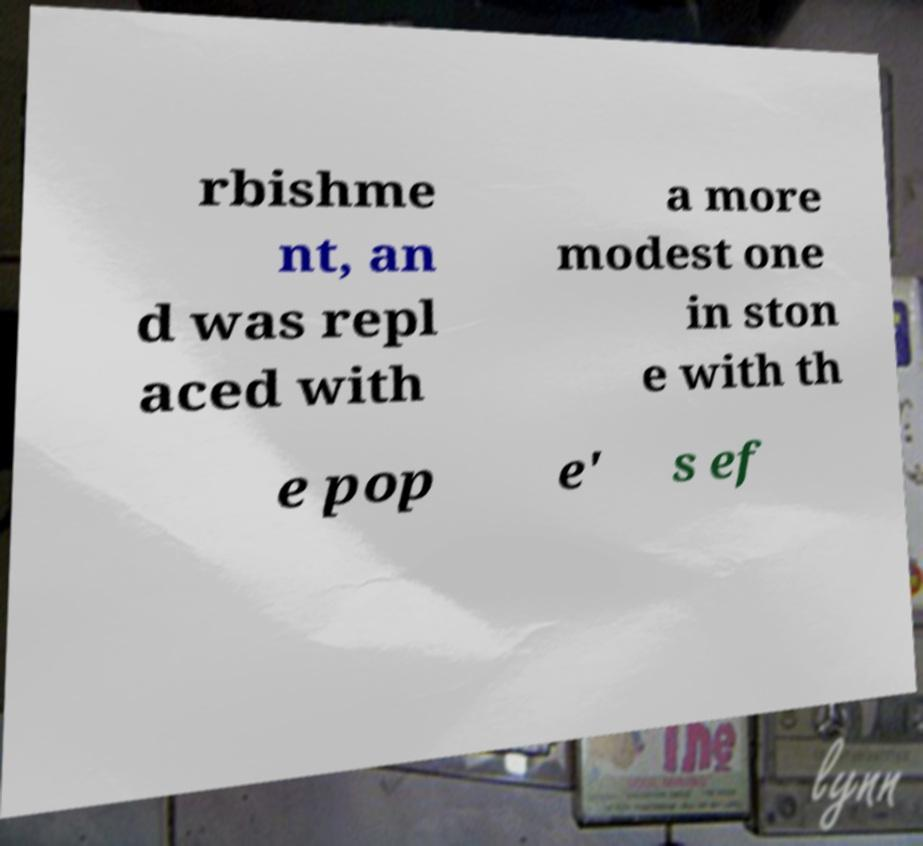There's text embedded in this image that I need extracted. Can you transcribe it verbatim? rbishme nt, an d was repl aced with a more modest one in ston e with th e pop e' s ef 